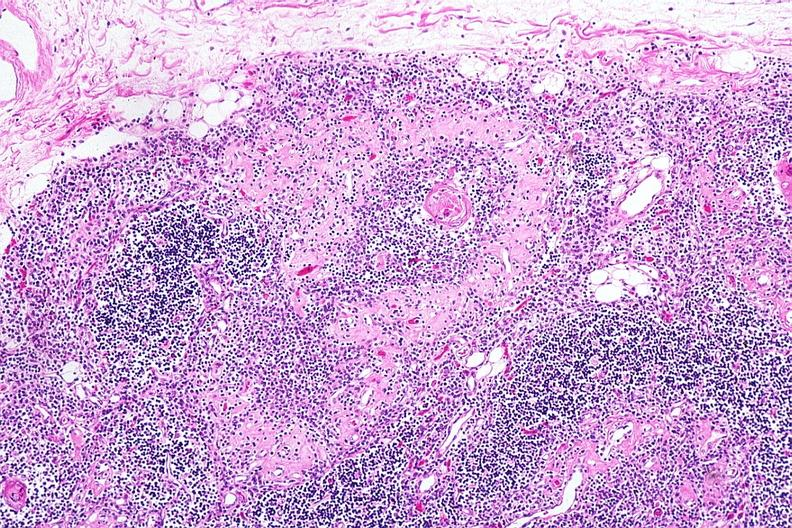s thymus present?
Answer the question using a single word or phrase. Yes 